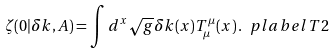<formula> <loc_0><loc_0><loc_500><loc_500>\zeta ( 0 | \delta k , A ) = \int d ^ { x } \sqrt { g } \delta k ( x ) T _ { \mu } ^ { \mu } ( x ) \, . \ p l a b e l { T 2 }</formula> 